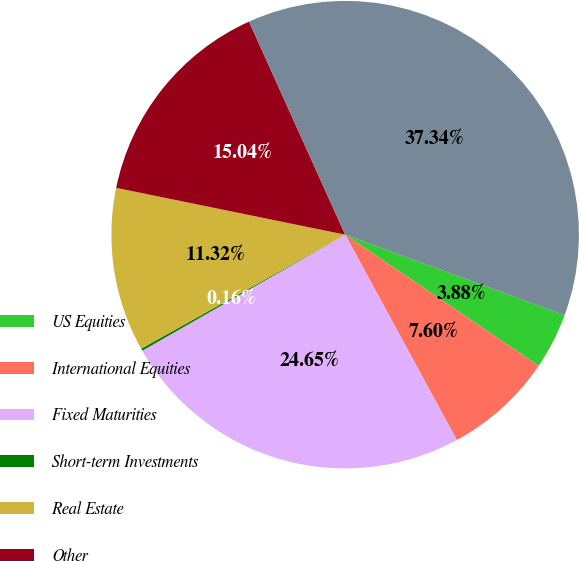Convert chart. <chart><loc_0><loc_0><loc_500><loc_500><pie_chart><fcel>US Equities<fcel>International Equities<fcel>Fixed Maturities<fcel>Short-term Investments<fcel>Real Estate<fcel>Other<fcel>Total<nl><fcel>3.88%<fcel>7.6%<fcel>24.65%<fcel>0.16%<fcel>11.32%<fcel>15.04%<fcel>37.34%<nl></chart> 